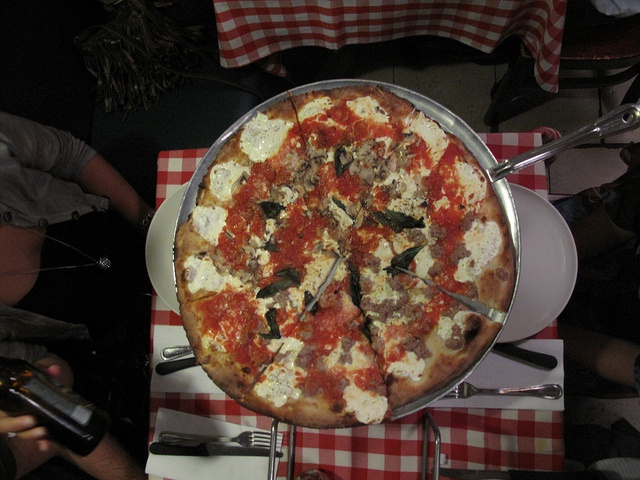Describe the objects in this image and their specific colors. I can see pizza in black, maroon, brown, and tan tones, dining table in black, maroon, gray, and brown tones, people in black, maroon, brown, and gray tones, chair in black and gray tones, and bottle in black, gray, and maroon tones in this image. 